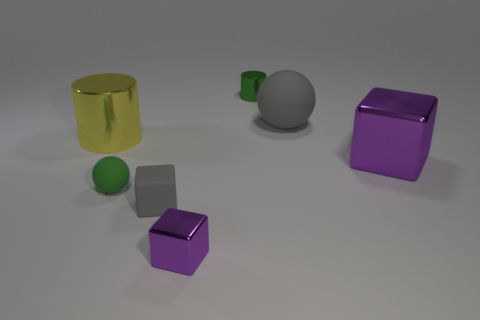Add 2 big green rubber cubes. How many objects exist? 9 Subtract all cubes. How many objects are left? 4 Subtract 0 red balls. How many objects are left? 7 Subtract all large yellow metallic cylinders. Subtract all tiny green metallic things. How many objects are left? 5 Add 2 big balls. How many big balls are left? 3 Add 1 big yellow things. How many big yellow things exist? 2 